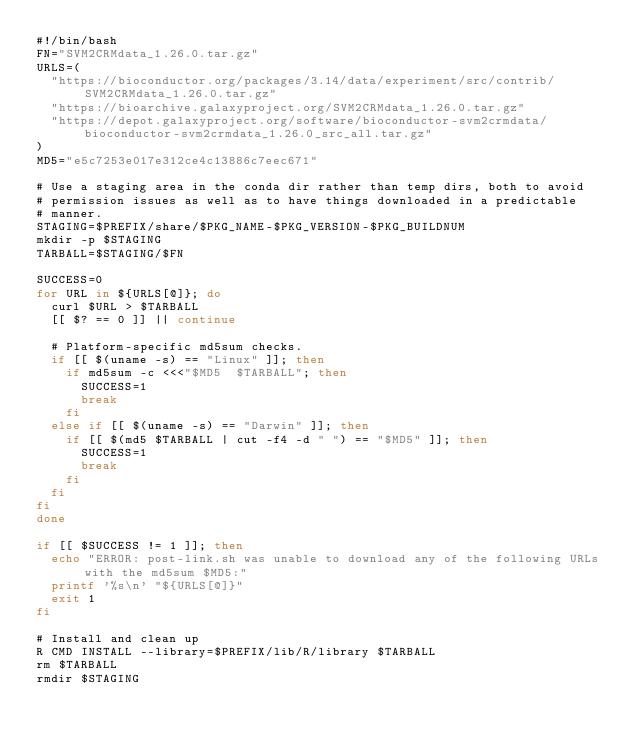Convert code to text. <code><loc_0><loc_0><loc_500><loc_500><_Bash_>#!/bin/bash
FN="SVM2CRMdata_1.26.0.tar.gz"
URLS=(
  "https://bioconductor.org/packages/3.14/data/experiment/src/contrib/SVM2CRMdata_1.26.0.tar.gz"
  "https://bioarchive.galaxyproject.org/SVM2CRMdata_1.26.0.tar.gz"
  "https://depot.galaxyproject.org/software/bioconductor-svm2crmdata/bioconductor-svm2crmdata_1.26.0_src_all.tar.gz"
)
MD5="e5c7253e017e312ce4c13886c7eec671"

# Use a staging area in the conda dir rather than temp dirs, both to avoid
# permission issues as well as to have things downloaded in a predictable
# manner.
STAGING=$PREFIX/share/$PKG_NAME-$PKG_VERSION-$PKG_BUILDNUM
mkdir -p $STAGING
TARBALL=$STAGING/$FN

SUCCESS=0
for URL in ${URLS[@]}; do
  curl $URL > $TARBALL
  [[ $? == 0 ]] || continue

  # Platform-specific md5sum checks.
  if [[ $(uname -s) == "Linux" ]]; then
    if md5sum -c <<<"$MD5  $TARBALL"; then
      SUCCESS=1
      break
    fi
  else if [[ $(uname -s) == "Darwin" ]]; then
    if [[ $(md5 $TARBALL | cut -f4 -d " ") == "$MD5" ]]; then
      SUCCESS=1
      break
    fi
  fi
fi
done

if [[ $SUCCESS != 1 ]]; then
  echo "ERROR: post-link.sh was unable to download any of the following URLs with the md5sum $MD5:"
  printf '%s\n' "${URLS[@]}"
  exit 1
fi

# Install and clean up
R CMD INSTALL --library=$PREFIX/lib/R/library $TARBALL
rm $TARBALL
rmdir $STAGING
</code> 